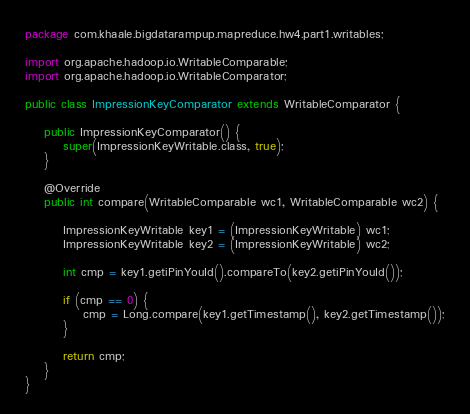Convert code to text. <code><loc_0><loc_0><loc_500><loc_500><_Java_>package com.khaale.bigdatarampup.mapreduce.hw4.part1.writables;

import org.apache.hadoop.io.WritableComparable;
import org.apache.hadoop.io.WritableComparator;

public class ImpressionKeyComparator extends WritableComparator {

    public ImpressionKeyComparator() {
        super(ImpressionKeyWritable.class, true);
    }

    @Override
    public int compare(WritableComparable wc1, WritableComparable wc2) {

        ImpressionKeyWritable key1 = (ImpressionKeyWritable) wc1;
        ImpressionKeyWritable key2 = (ImpressionKeyWritable) wc2;

        int cmp = key1.getiPinYouId().compareTo(key2.getiPinYouId());

        if (cmp == 0) {
            cmp = Long.compare(key1.getTimestamp(), key2.getTimestamp());
        }

        return cmp;
    }
}
</code> 